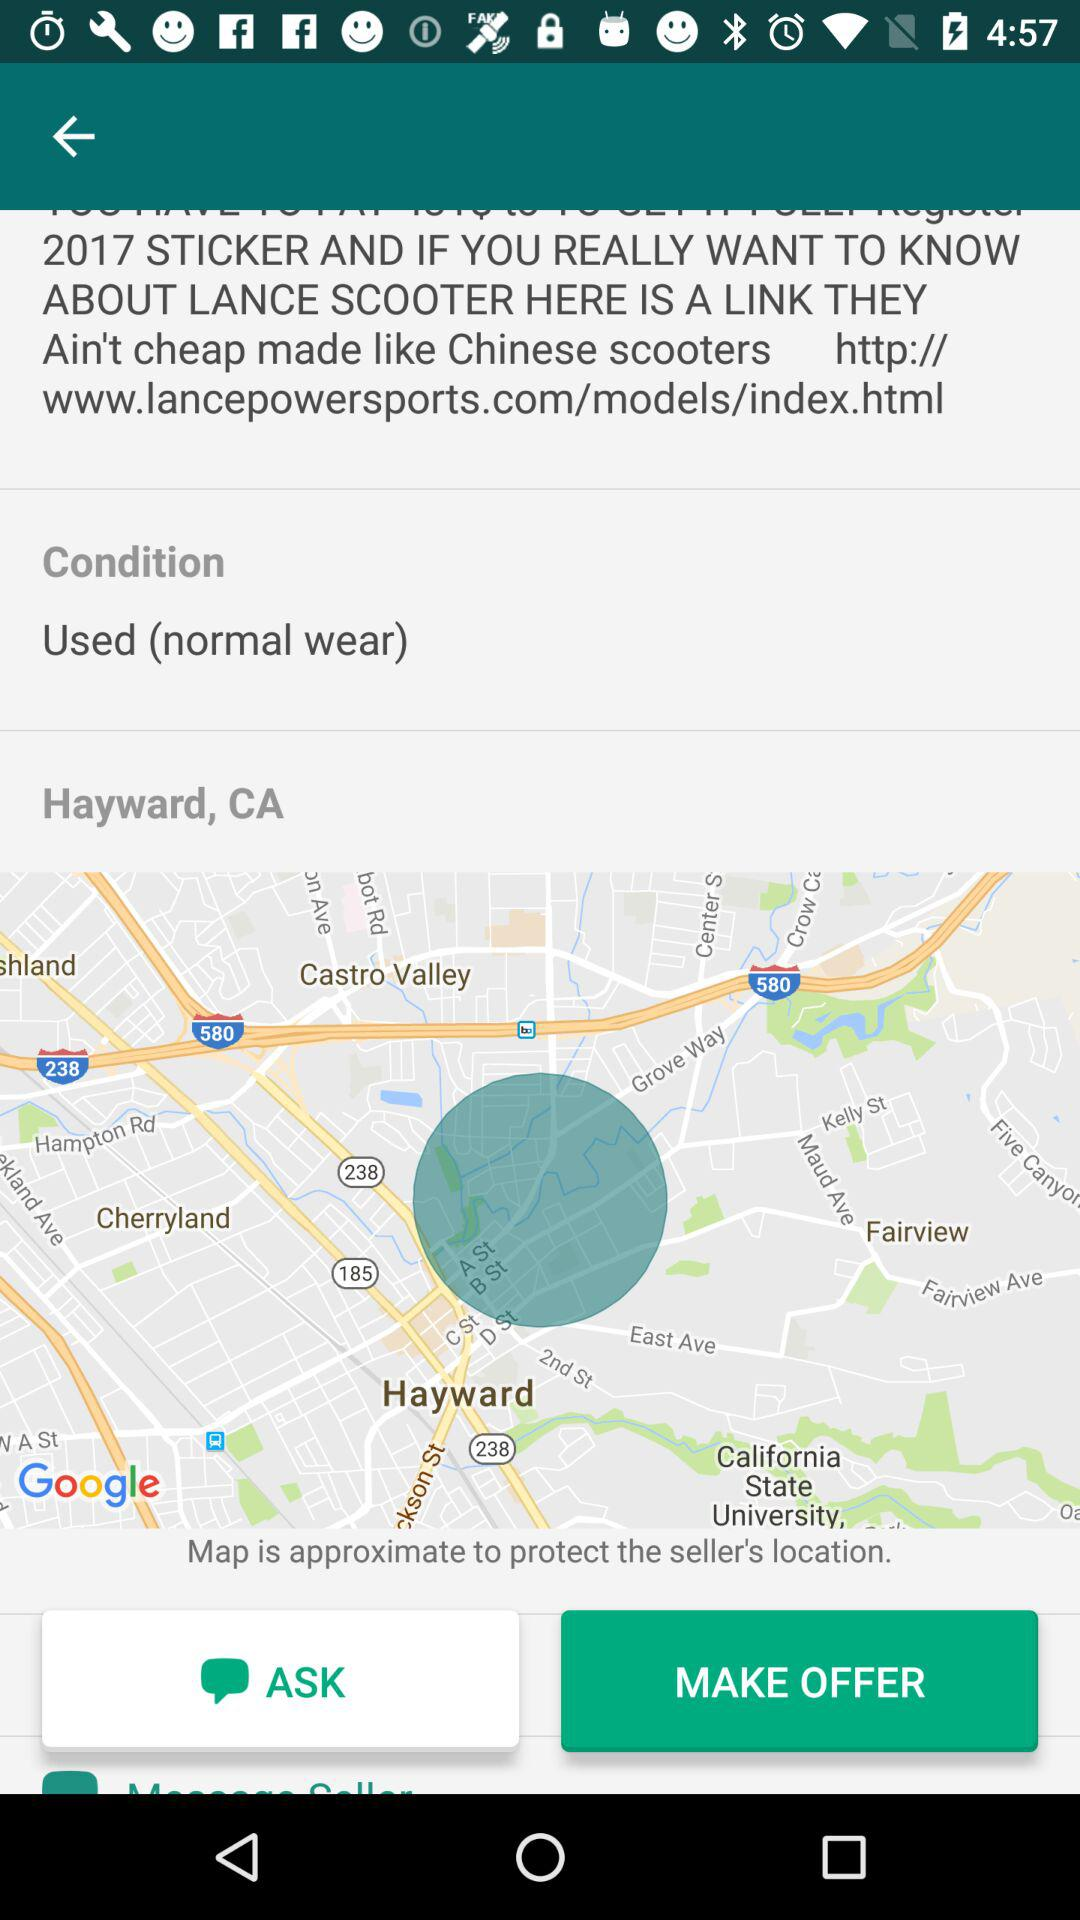What is the condition? The condition is used (normal wear). 